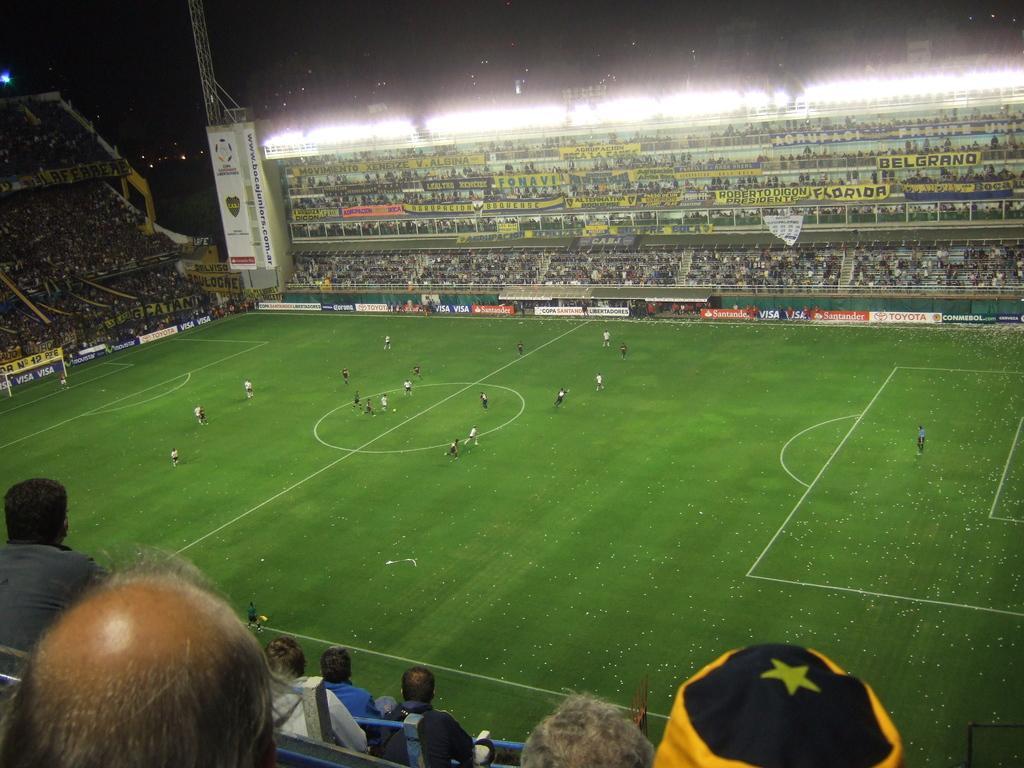Could you give a brief overview of what you see in this image? This is the picture of a stadium. In this image there are group of people and there are boards, there is text on the boards. At the bottom there are group of people running on the grass. At the top there are lights and there is sky. 